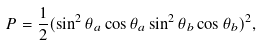Convert formula to latex. <formula><loc_0><loc_0><loc_500><loc_500>P = \frac { 1 } { 2 } ( \sin ^ { 2 } \theta _ { a } \cos \theta _ { a } \sin ^ { 2 } \theta _ { b } \cos \theta _ { b } ) ^ { 2 } ,</formula> 